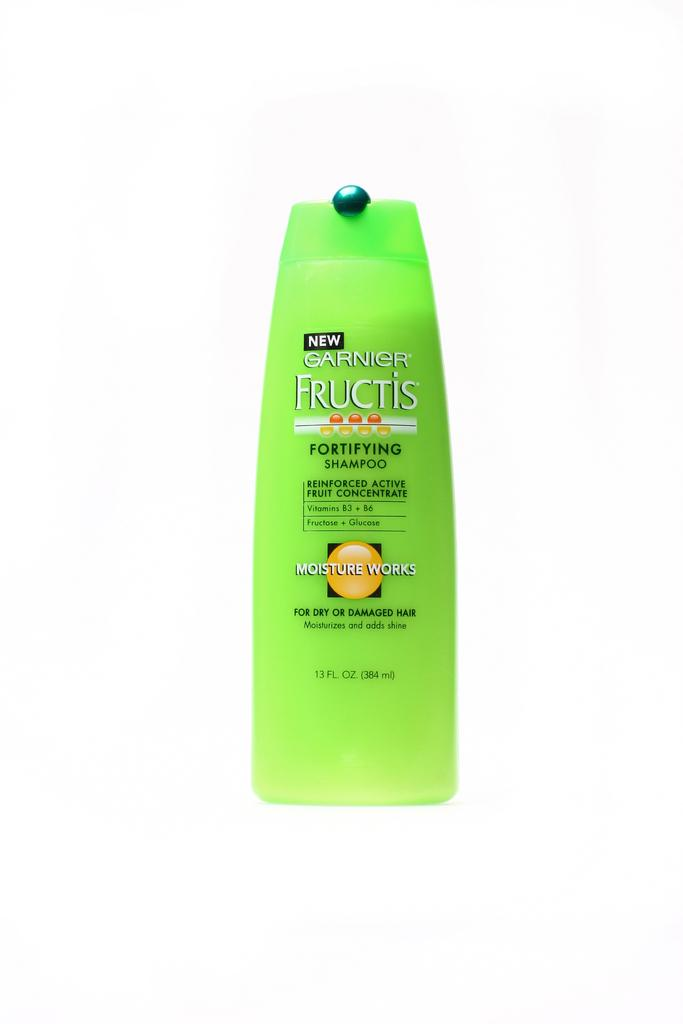Provide a one-sentence caption for the provided image. A green bottle of Fructis Fortifying Shampoo that says Moisture Works on it. 